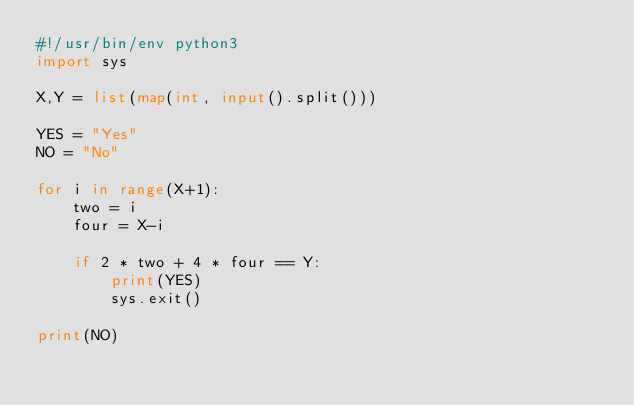Convert code to text. <code><loc_0><loc_0><loc_500><loc_500><_Python_>#!/usr/bin/env python3
import sys

X,Y = list(map(int, input().split()))

YES = "Yes"  
NO = "No" 

for i in range(X+1):
    two = i
    four = X-i
    
    if 2 * two + 4 * four == Y:
        print(YES)
        sys.exit()

print(NO)</code> 